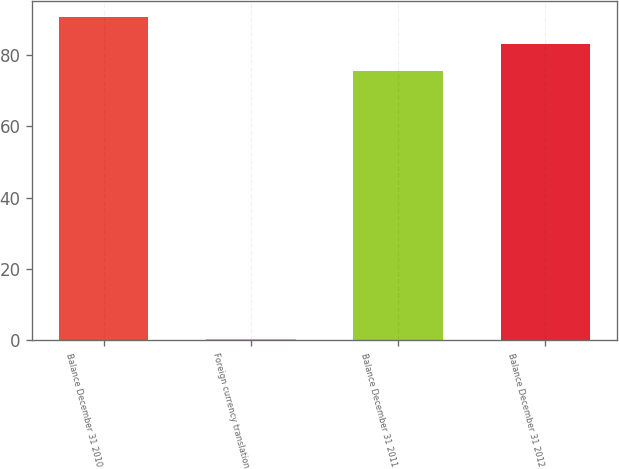Convert chart. <chart><loc_0><loc_0><loc_500><loc_500><bar_chart><fcel>Balance December 31 2010<fcel>Foreign currency translation<fcel>Balance December 31 2011<fcel>Balance December 31 2012<nl><fcel>90.72<fcel>0.3<fcel>75.6<fcel>83.16<nl></chart> 